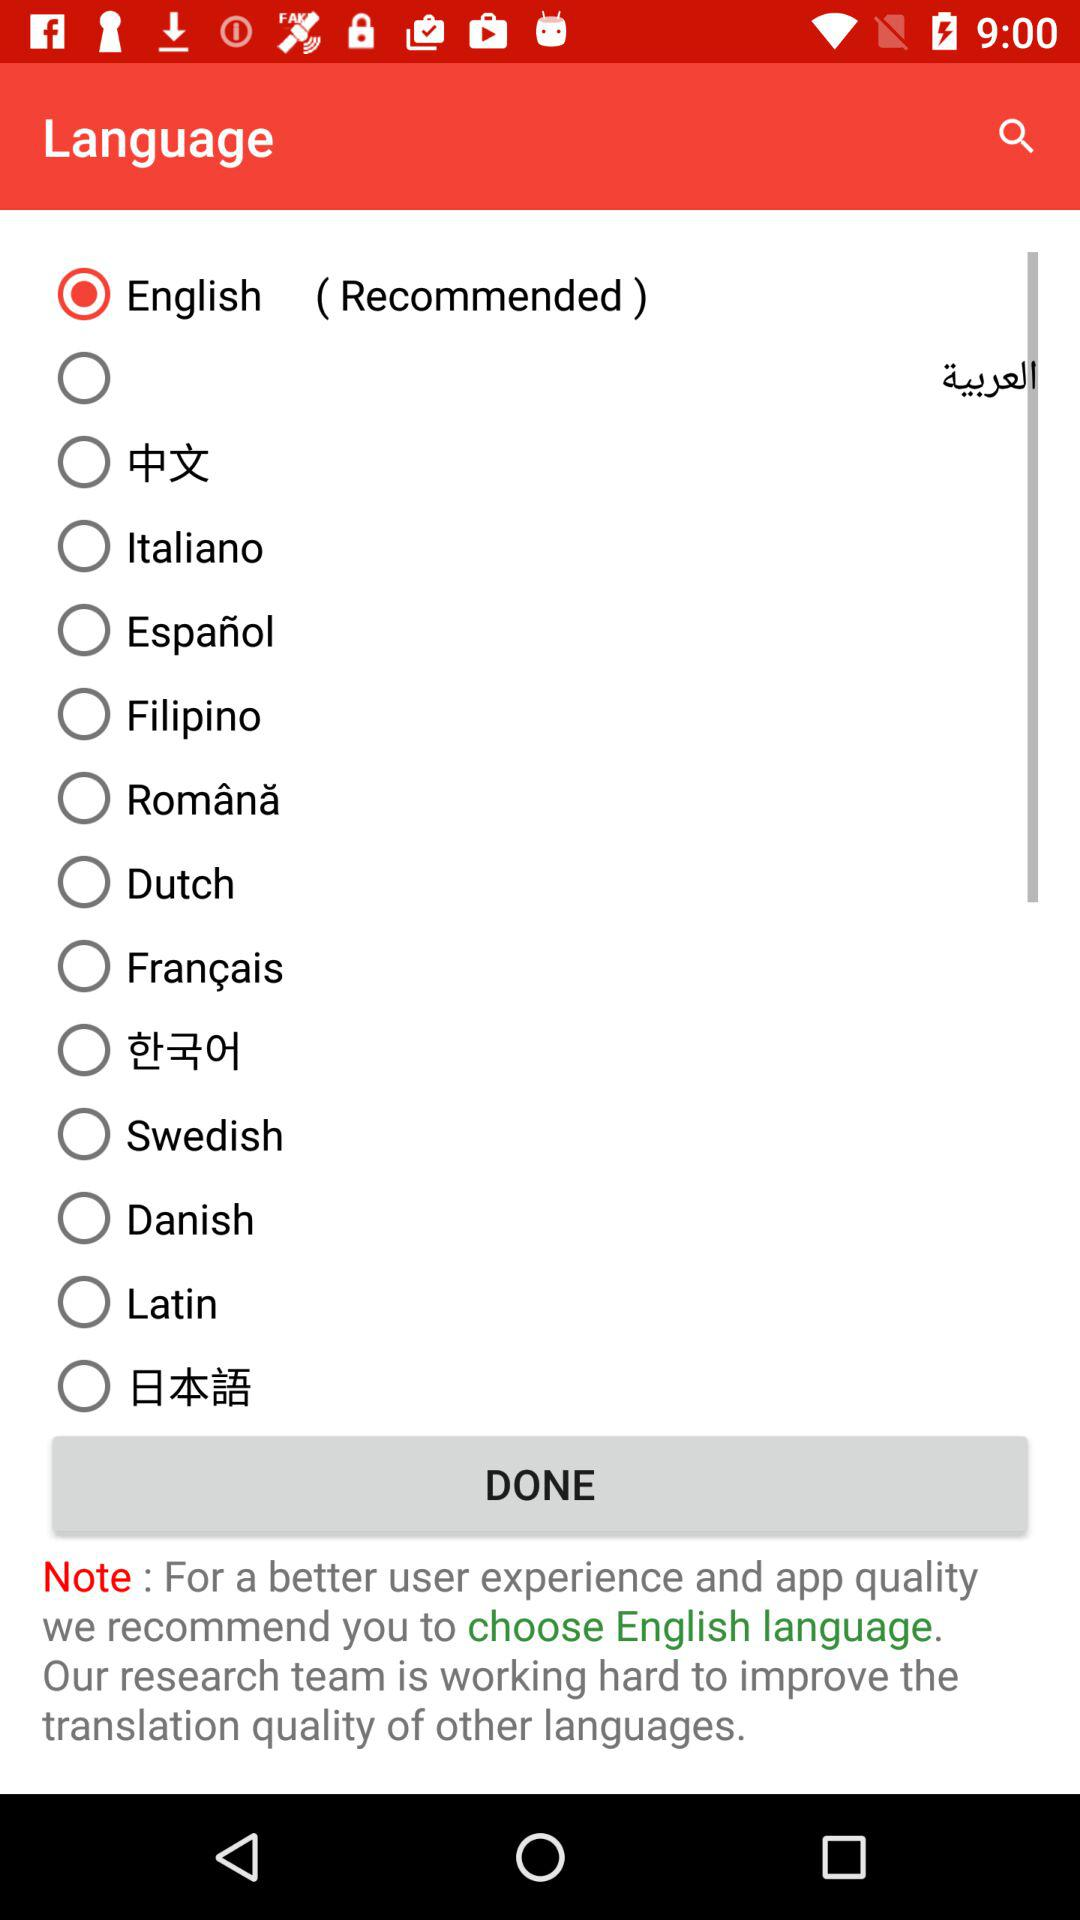Which language has been chosen? The chosen language is English. 